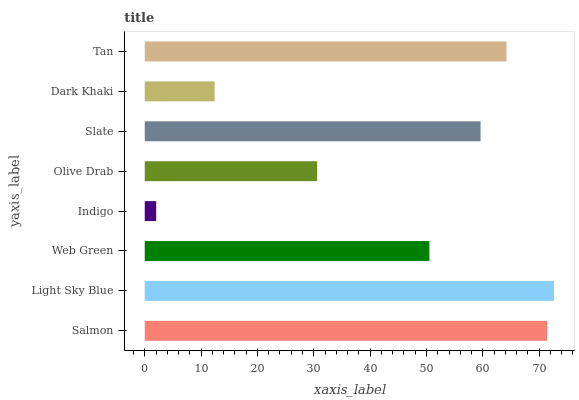Is Indigo the minimum?
Answer yes or no. Yes. Is Light Sky Blue the maximum?
Answer yes or no. Yes. Is Web Green the minimum?
Answer yes or no. No. Is Web Green the maximum?
Answer yes or no. No. Is Light Sky Blue greater than Web Green?
Answer yes or no. Yes. Is Web Green less than Light Sky Blue?
Answer yes or no. Yes. Is Web Green greater than Light Sky Blue?
Answer yes or no. No. Is Light Sky Blue less than Web Green?
Answer yes or no. No. Is Slate the high median?
Answer yes or no. Yes. Is Web Green the low median?
Answer yes or no. Yes. Is Web Green the high median?
Answer yes or no. No. Is Olive Drab the low median?
Answer yes or no. No. 